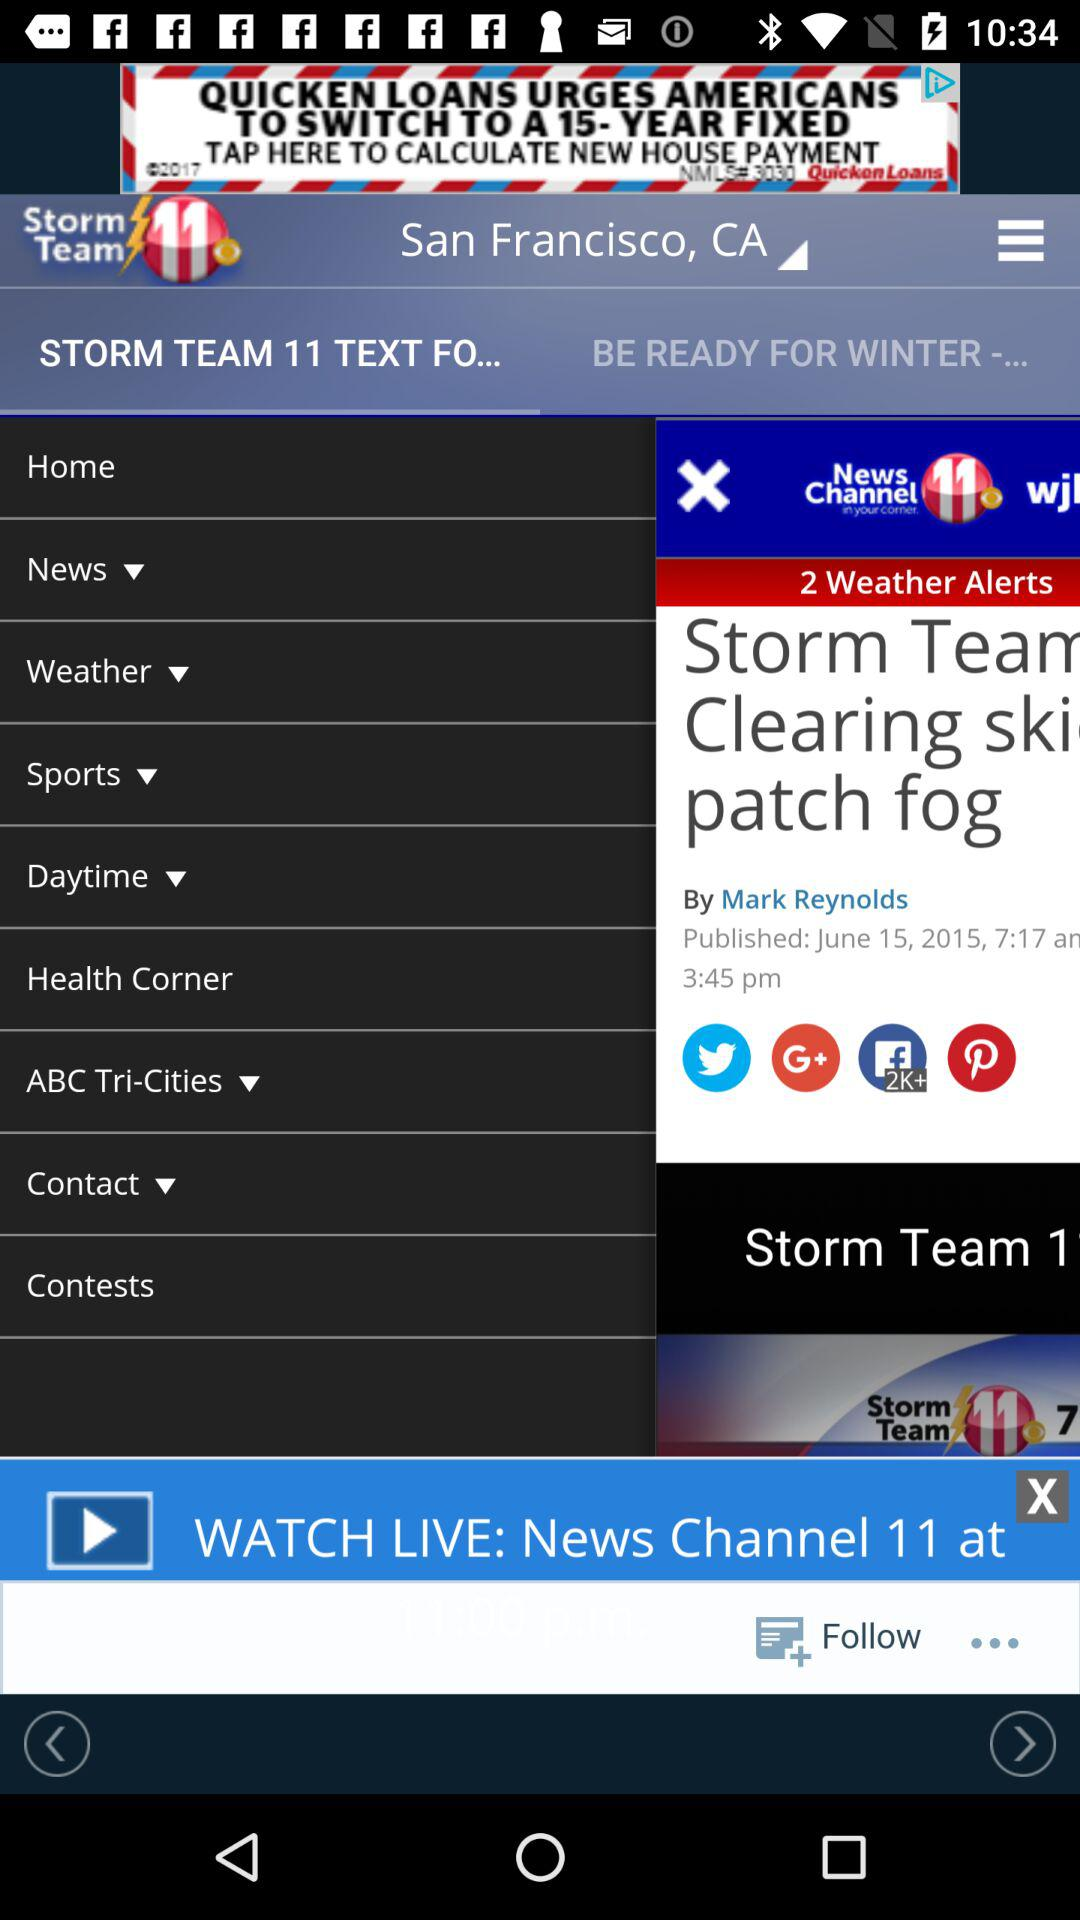What is the location? The location is San Francisco, CA. 